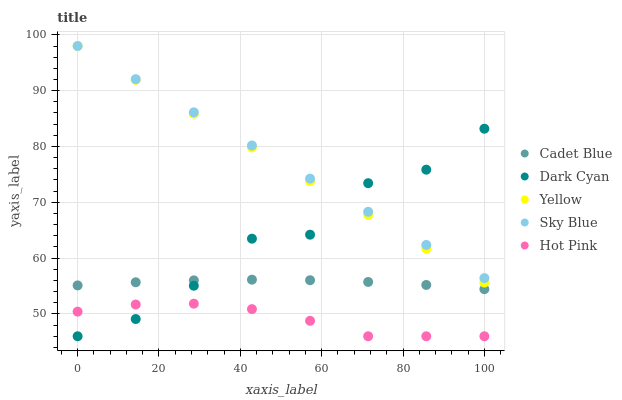Does Hot Pink have the minimum area under the curve?
Answer yes or no. Yes. Does Sky Blue have the maximum area under the curve?
Answer yes or no. Yes. Does Cadet Blue have the minimum area under the curve?
Answer yes or no. No. Does Cadet Blue have the maximum area under the curve?
Answer yes or no. No. Is Yellow the smoothest?
Answer yes or no. Yes. Is Dark Cyan the roughest?
Answer yes or no. Yes. Is Sky Blue the smoothest?
Answer yes or no. No. Is Sky Blue the roughest?
Answer yes or no. No. Does Dark Cyan have the lowest value?
Answer yes or no. Yes. Does Cadet Blue have the lowest value?
Answer yes or no. No. Does Yellow have the highest value?
Answer yes or no. Yes. Does Cadet Blue have the highest value?
Answer yes or no. No. Is Cadet Blue less than Sky Blue?
Answer yes or no. Yes. Is Sky Blue greater than Hot Pink?
Answer yes or no. Yes. Does Dark Cyan intersect Cadet Blue?
Answer yes or no. Yes. Is Dark Cyan less than Cadet Blue?
Answer yes or no. No. Is Dark Cyan greater than Cadet Blue?
Answer yes or no. No. Does Cadet Blue intersect Sky Blue?
Answer yes or no. No. 